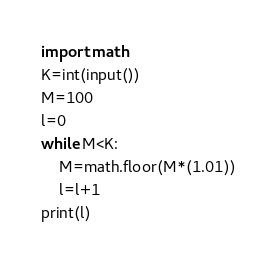Convert code to text. <code><loc_0><loc_0><loc_500><loc_500><_Python_>import math
K=int(input())
M=100
l=0
while M<K:
    M=math.floor(M*(1.01))
    l=l+1
print(l)</code> 